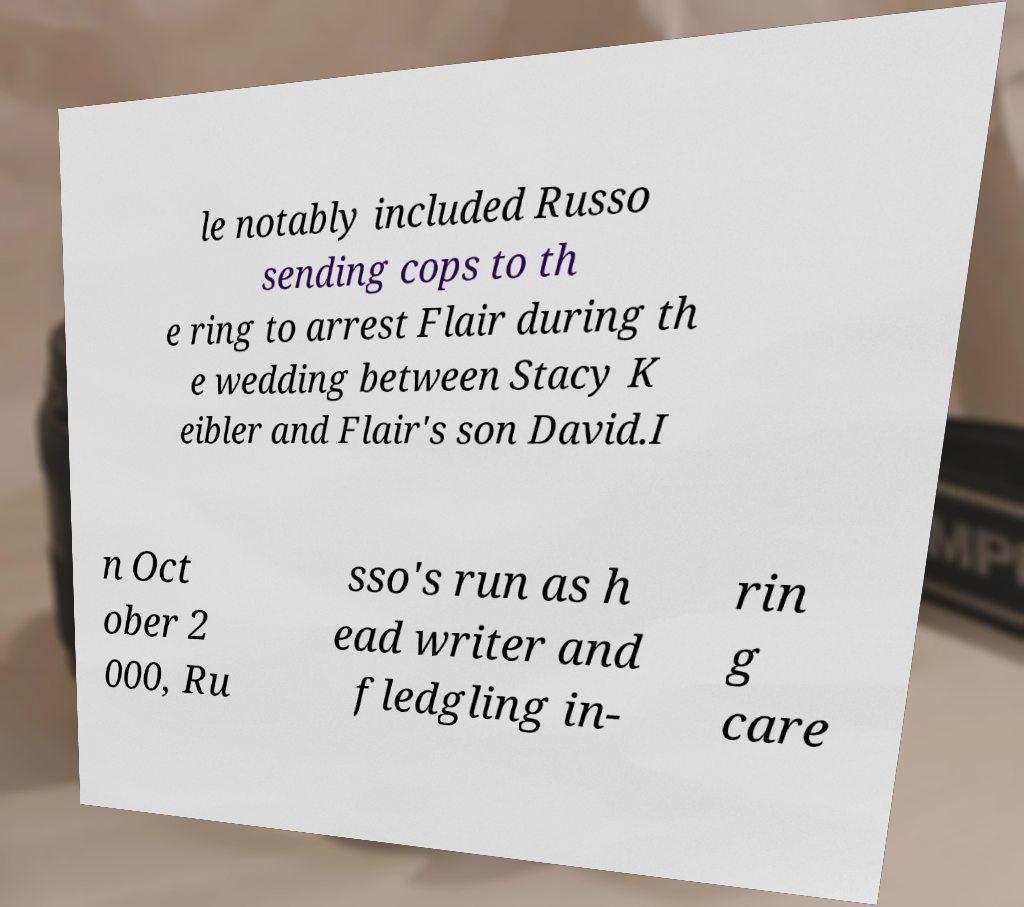Could you assist in decoding the text presented in this image and type it out clearly? le notably included Russo sending cops to th e ring to arrest Flair during th e wedding between Stacy K eibler and Flair's son David.I n Oct ober 2 000, Ru sso's run as h ead writer and fledgling in- rin g care 